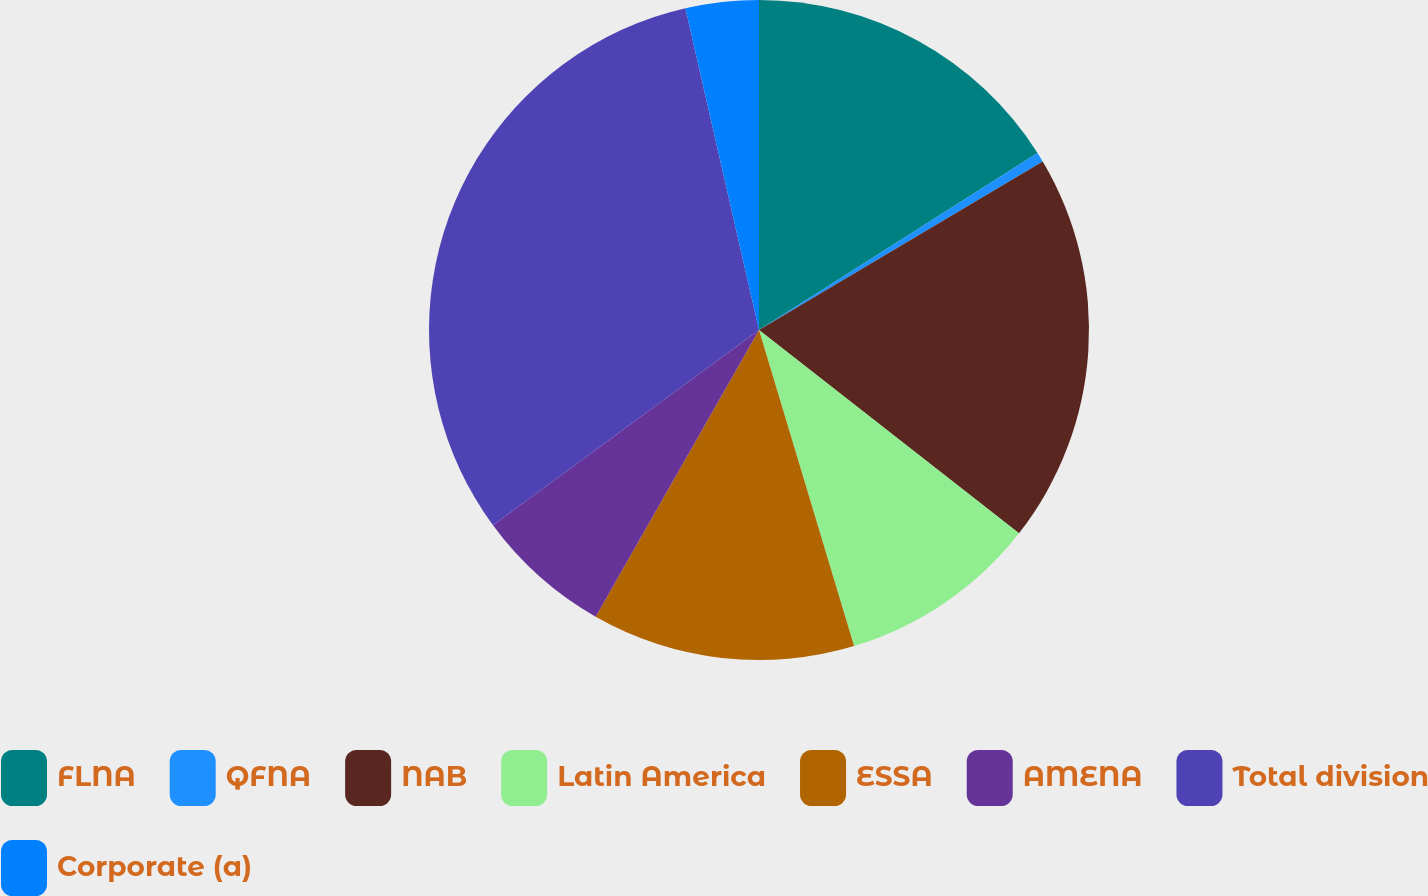Convert chart. <chart><loc_0><loc_0><loc_500><loc_500><pie_chart><fcel>FLNA<fcel>QFNA<fcel>NAB<fcel>Latin America<fcel>ESSA<fcel>AMENA<fcel>Total division<fcel>Corporate (a)<nl><fcel>15.99%<fcel>0.48%<fcel>19.09%<fcel>9.79%<fcel>12.89%<fcel>6.68%<fcel>31.5%<fcel>3.58%<nl></chart> 